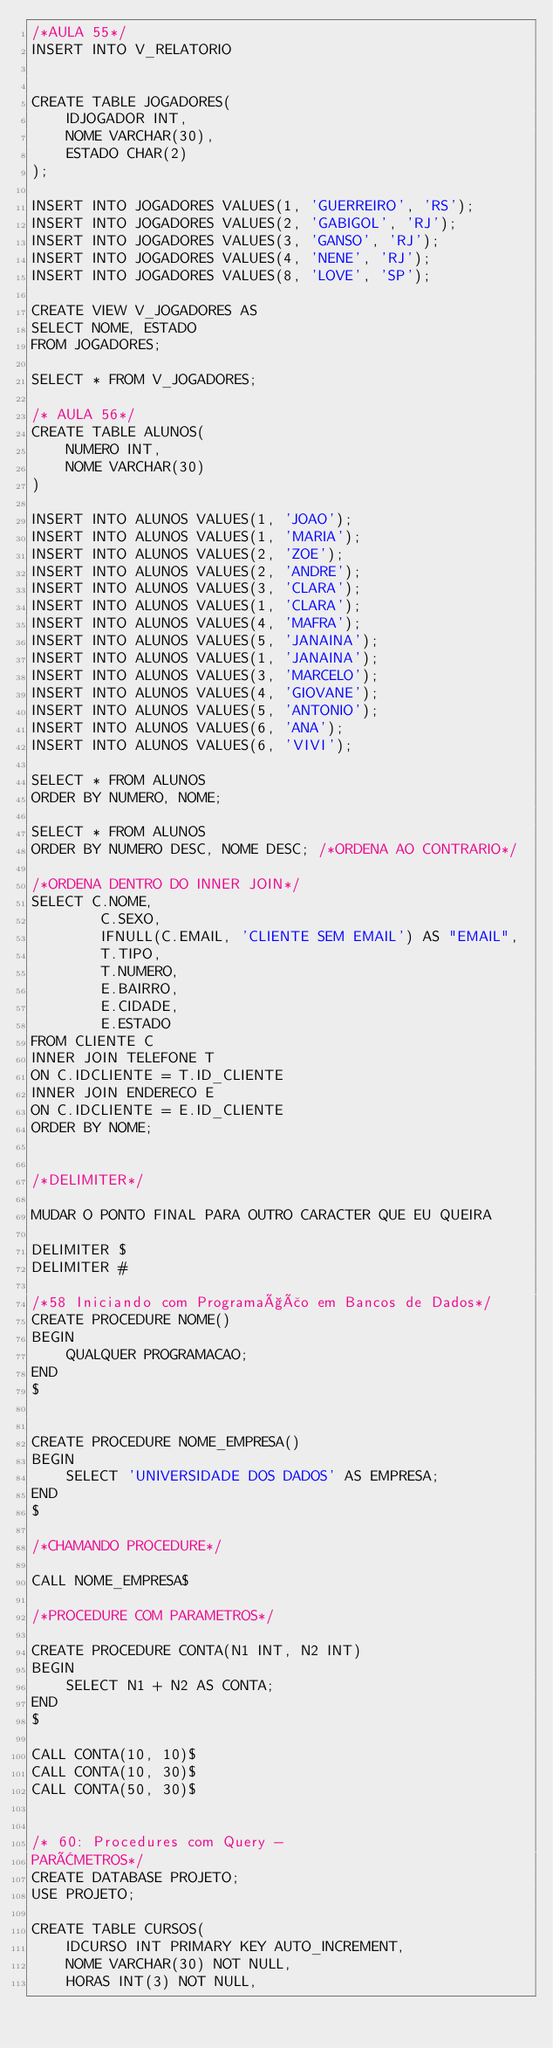<code> <loc_0><loc_0><loc_500><loc_500><_SQL_>/*AULA 55*/
INSERT INTO V_RELATORIO


CREATE TABLE JOGADORES(
	IDJOGADOR INT,
	NOME VARCHAR(30),
	ESTADO CHAR(2)
);

INSERT INTO JOGADORES VALUES(1, 'GUERREIRO', 'RS');
INSERT INTO JOGADORES VALUES(2, 'GABIGOL', 'RJ');
INSERT INTO JOGADORES VALUES(3, 'GANSO', 'RJ');
INSERT INTO JOGADORES VALUES(4, 'NENE', 'RJ');
INSERT INTO JOGADORES VALUES(8, 'LOVE', 'SP');

CREATE VIEW V_JOGADORES AS 
SELECT NOME, ESTADO
FROM JOGADORES;

SELECT * FROM V_JOGADORES;

/* AULA 56*/
CREATE TABLE ALUNOS(
	NUMERO INT,
	NOME VARCHAR(30)
)

INSERT INTO ALUNOS VALUES(1, 'JOAO');
INSERT INTO ALUNOS VALUES(1, 'MARIA');
INSERT INTO ALUNOS VALUES(2, 'ZOE');
INSERT INTO ALUNOS VALUES(2, 'ANDRE');
INSERT INTO ALUNOS VALUES(3, 'CLARA');
INSERT INTO ALUNOS VALUES(1, 'CLARA');
INSERT INTO ALUNOS VALUES(4, 'MAFRA');
INSERT INTO ALUNOS VALUES(5, 'JANAINA');
INSERT INTO ALUNOS VALUES(1, 'JANAINA');
INSERT INTO ALUNOS VALUES(3, 'MARCELO');
INSERT INTO ALUNOS VALUES(4, 'GIOVANE');
INSERT INTO ALUNOS VALUES(5, 'ANTONIO');
INSERT INTO ALUNOS VALUES(6, 'ANA');
INSERT INTO ALUNOS VALUES(6, 'VIVI');

SELECT * FROM ALUNOS
ORDER BY NUMERO, NOME;

SELECT * FROM ALUNOS
ORDER BY NUMERO DESC, NOME DESC; /*ORDENA AO CONTRARIO*/

/*ORDENA DENTRO DO INNER JOIN*/
SELECT C.NOME,
		C.SEXO,
		IFNULL(C.EMAIL, 'CLIENTE SEM EMAIL') AS "EMAIL",
		T.TIPO, 
		T.NUMERO, 
		E.BAIRRO,
		E.CIDADE,
		E.ESTADO
FROM CLIENTE C
INNER JOIN TELEFONE T
ON C.IDCLIENTE = T.ID_CLIENTE
INNER JOIN ENDERECO E
ON C.IDCLIENTE = E.ID_CLIENTE
ORDER BY NOME;


/*DELIMITER*/

MUDAR O PONTO FINAL PARA OUTRO CARACTER QUE EU QUEIRA

DELIMITER $
DELIMITER #

/*58 Iniciando com Programação em Bancos de Dados*/
CREATE PROCEDURE NOME()
BEGIN
	QUALQUER PROGRAMACAO;
END 
$


CREATE PROCEDURE NOME_EMPRESA()
BEGIN
	SELECT 'UNIVERSIDADE DOS DADOS' AS EMPRESA;
END
$

/*CHAMANDO PROCEDURE*/

CALL NOME_EMPRESA$

/*PROCEDURE COM PARAMETROS*/

CREATE PROCEDURE CONTA(N1 INT, N2 INT)
BEGIN
	SELECT N1 + N2 AS CONTA;
END
$

CALL CONTA(10, 10)$
CALL CONTA(10, 30)$
CALL CONTA(50, 30)$


/* 60: Procedures com Query -
PARÂMETROS*/
CREATE DATABASE PROJETO;
USE PROJETO;

CREATE TABLE CURSOS(
	IDCURSO INT PRIMARY KEY AUTO_INCREMENT,
	NOME VARCHAR(30) NOT NULL,
	HORAS INT(3) NOT NULL,</code> 